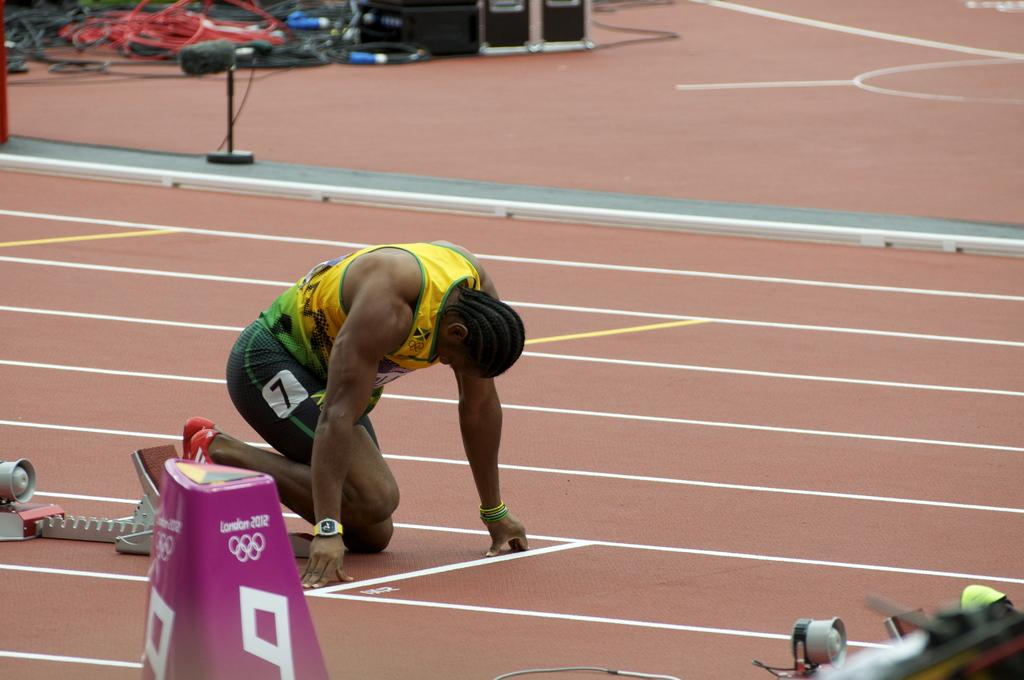Who or what is present in the image? There is a person in the image. What is the person doing or where are they located? The person is on a track. What else can be seen in the image besides the person? There are objects in the image. Can you describe the background of the image? There are cables and devices in the background of the image. What type of parcel is being delivered to the person in the image? There is no parcel being delivered in the image; it only features a person on a track, objects, cables, and devices in the background. 